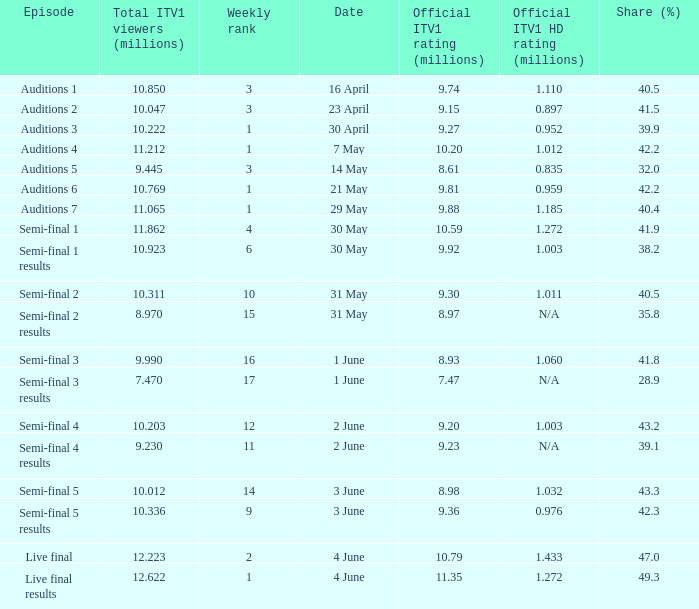What was the official ITV1 rating in millions of the Live Final Results episode? 11.35. 